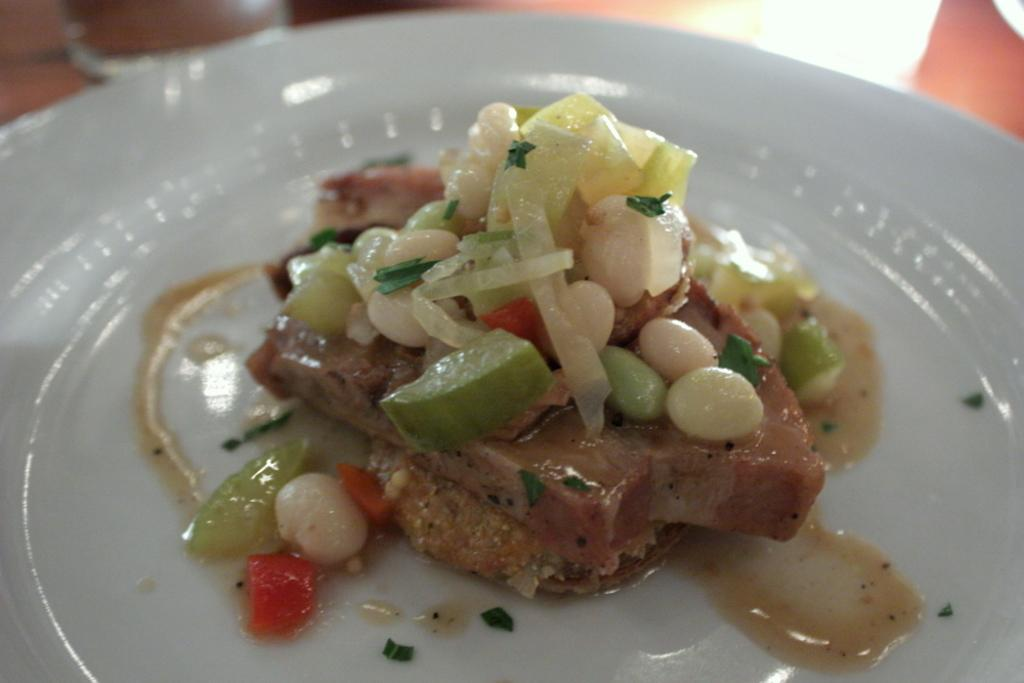What object is present on the plate in the image? There is food on the plate in the image. What color is the plate? The plate is white. Can you describe the background of the image? The background of the image is blurred. How many pizzas are visible on the plate in the image? There are no pizzas present on the plate in the image. What type of oatmeal can be seen on the plate in the image? There is no oatmeal visible on the plate in the image. 